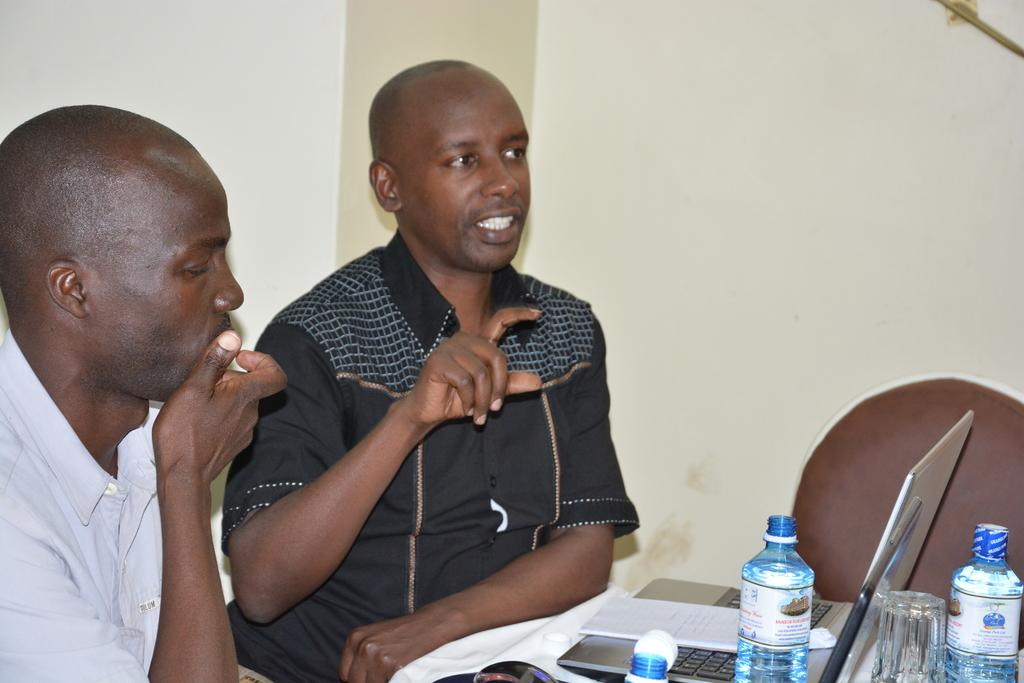How many people are in the image? There are two men in the image. What is one of the men doing? One of the men is talking. What objects can be seen in the image? There is a bottle, a laptop, a glass, a cloth, and a chair in the image. What is visible in the background of the image? There is a wall in the background of the image. What type of fiction is the man reading from the hose in the image? There is no hose or fiction present in the image. What type of spoon is the man using to stir the laptop in the image? There is no spoon or stirring activity involving the laptop in the image. 